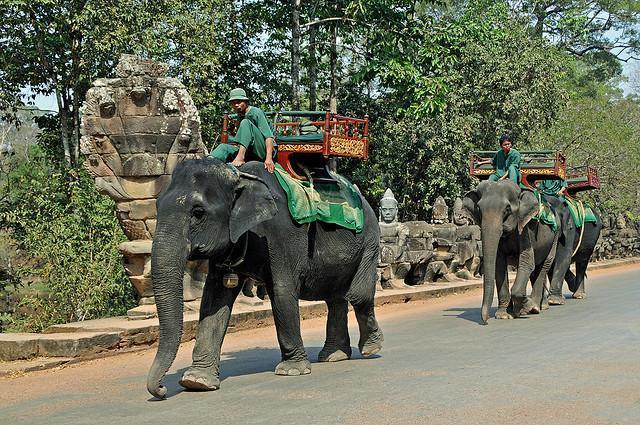How many passengers are they carrying?
Give a very brief answer. 2. How many elephants are in the photo?
Give a very brief answer. 3. 